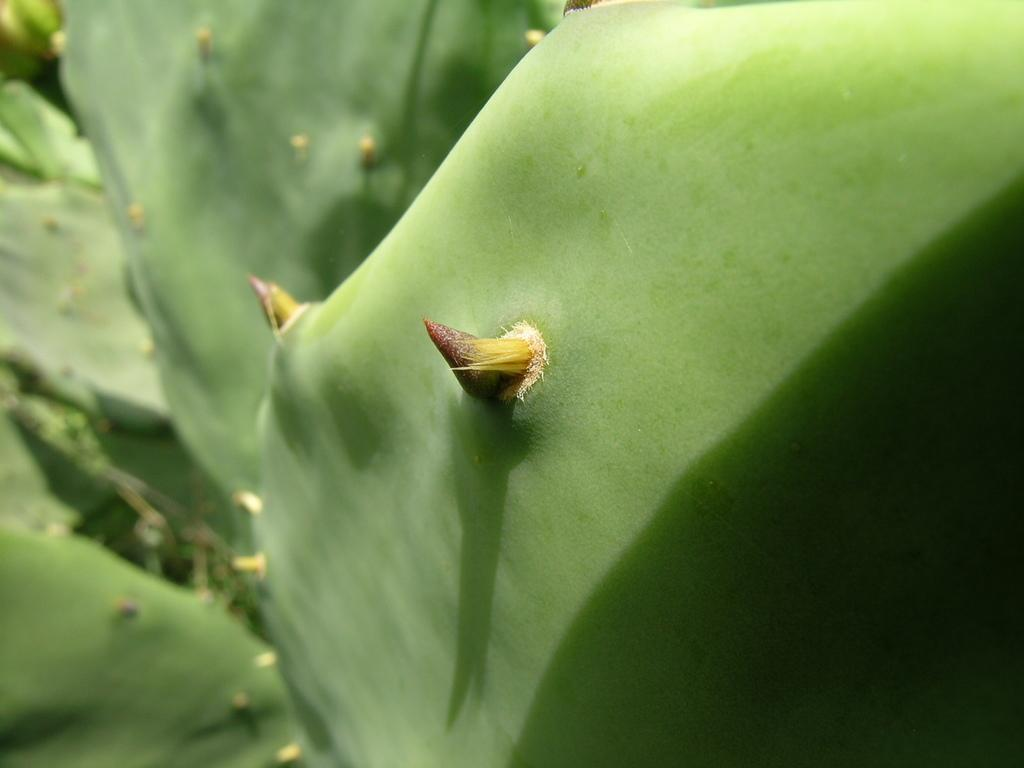What type of plants are featured in the image? The image contains leaves of cactus plants. What type of bun is sitting on the sofa in the image? There is no bun or sofa present in the image; it features leaves of cactus plants. How many pigs can be seen interacting with the cactus plants in the image? There are no pigs present in the image; it features leaves of cactus plants. 